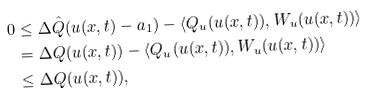<formula> <loc_0><loc_0><loc_500><loc_500>0 & \leq \Delta \hat { Q } ( u ( x , t ) - a _ { 1 } ) - \langle Q _ { u } ( u ( x , t ) ) , W _ { u } ( u ( x , t ) ) \rangle \\ & = \Delta Q ( u ( x , t ) ) - \langle Q _ { u } ( u ( x , t ) ) , W _ { u } ( u ( x , t ) ) \rangle \\ & \leq \Delta Q ( u ( x , t ) ) ,</formula> 